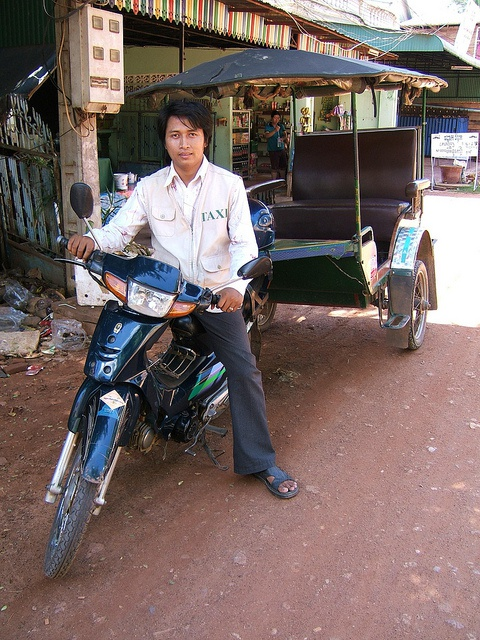Describe the objects in this image and their specific colors. I can see motorcycle in black, gray, lightgray, and maroon tones, people in black, lavender, and gray tones, and people in black, maroon, gray, and darkblue tones in this image. 